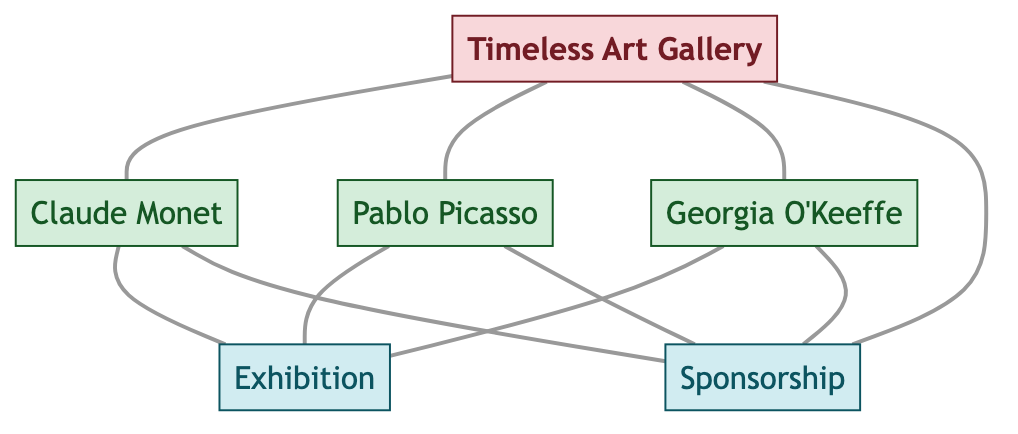What is the total number of artists represented in the diagram? The diagram indicates three distinct artists connected to the gallery. Each artist (Claude Monet, Pablo Picasso, Georgia O'Keeffe) is directly linked to "Timeless Art Gallery" as well as exhibitions and sponsorships. Counting these gives a total of three artists.
Answer: 3 What event features Claude Monet's work? Claude Monet is linked to the "Exhibition" event via the relationship "featured in." This direct connection shows that his work is displayed in the exhibition.
Answer: Exhibition Which artist receives sponsorship from "Timeless Art Gallery"? The diagram illustrates that "Timeless Art Gallery" provides sponsorship to the artists, including Claude Monet, Pablo Picasso, and Georgia O'Keeffe. Each artist is directly connected to the "Sponsorship" node, indicating they all receive this form of support from the gallery.
Answer: Claude Monet, Pablo Picasso, Georgia O'Keeffe How many events are represented in the diagram? Two events are noted in the diagram: "Exhibition" and "Sponsorship." Each of these is tied to relationships with the gallery and the artists. Counting these events shows there are two distinct events.
Answer: 2 What is the relationship between Pablo Picasso and the "Exhibition"? The diagram specifies a direct relationship indicating that Pablo Picasso is "featured in" the "Exhibition." This relationship showcases his portrayal within the event.
Answer: featured in Which entity is central to the relationships shown in the diagram? The "Timeless Art Gallery" is central as it connects to all artists, and its relationships illustrate hosting events and providing sponsorship. This centrality highlights the gallery's role in the art community depicted.
Answer: Timeless Art Gallery Are there any relationships showing collaboration with events? Yes, the "Exhibition" and "Sponsorship" are both events connected to the artists through various links showing how the gallery hosts exhibitions and provides sponsorship. These relationships indicate collaborative involvement with the events.
Answer: Yes What type of relationship does "Timeless Art Gallery" have with Georgia O'Keeffe? The relationship between "Timeless Art Gallery" and Georgia O'Keeffe is that the gallery "hosts" her work, indicating active support and involvement in exhibiting her art.
Answer: hosts 